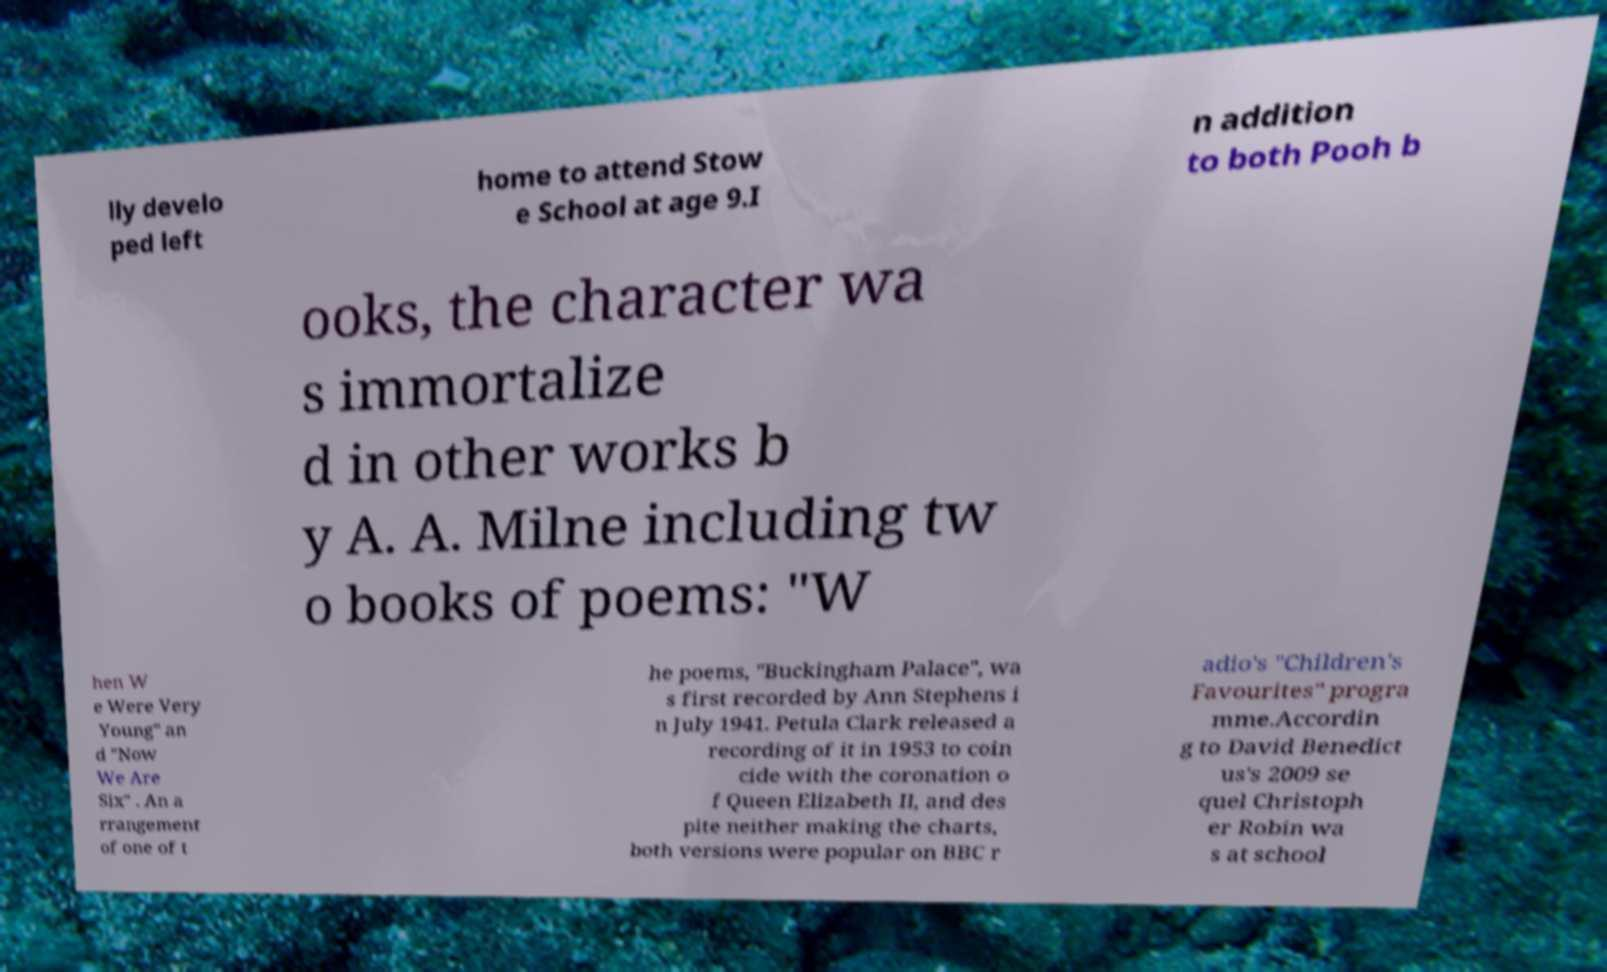Can you read and provide the text displayed in the image?This photo seems to have some interesting text. Can you extract and type it out for me? lly develo ped left home to attend Stow e School at age 9.I n addition to both Pooh b ooks, the character wa s immortalize d in other works b y A. A. Milne including tw o books of poems: "W hen W e Were Very Young" an d "Now We Are Six" . An a rrangement of one of t he poems, "Buckingham Palace", wa s first recorded by Ann Stephens i n July 1941. Petula Clark released a recording of it in 1953 to coin cide with the coronation o f Queen Elizabeth II, and des pite neither making the charts, both versions were popular on BBC r adio's "Children's Favourites" progra mme.Accordin g to David Benedict us's 2009 se quel Christoph er Robin wa s at school 